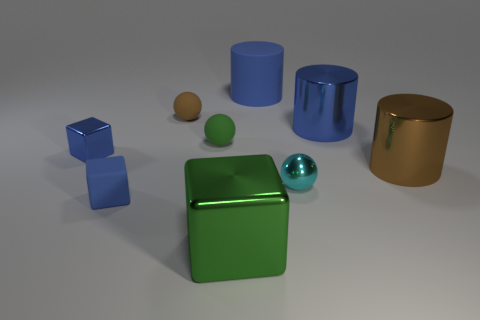There is a big shiny object that is in front of the big brown shiny object; what number of balls are right of it? To the right of the big shiny green cube, which is in front of the big brown cylinder, there is only one ball, and it's teal colored with a reflective surface. 